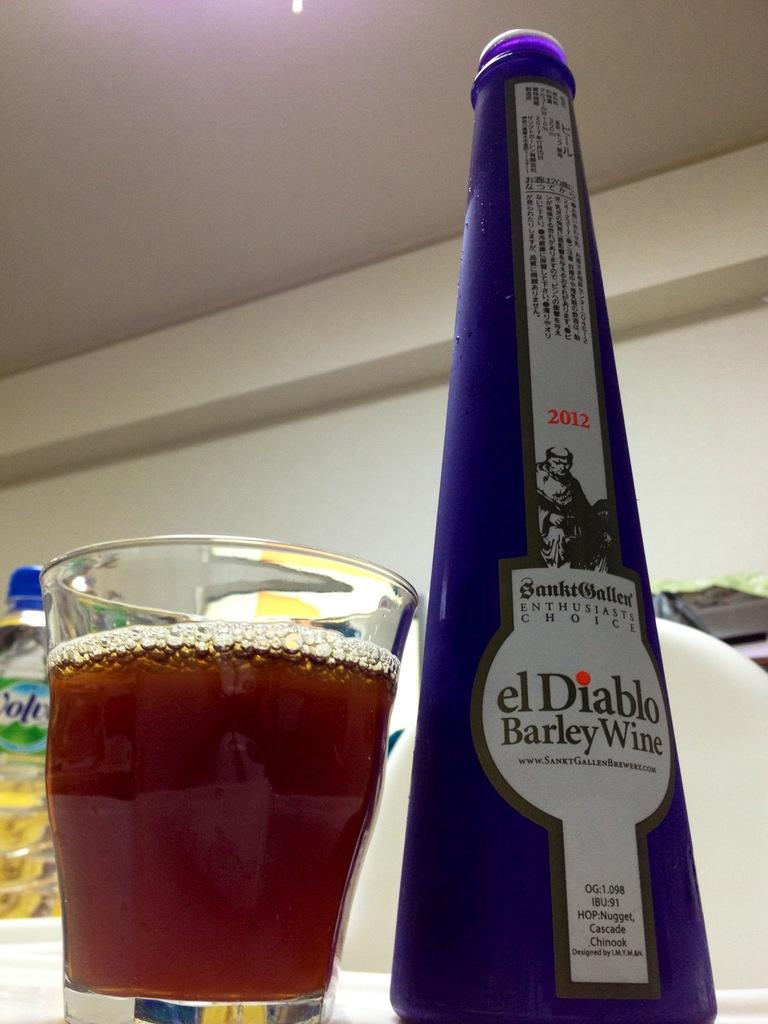When was the wine bottled?
Ensure brevity in your answer.  2012. 